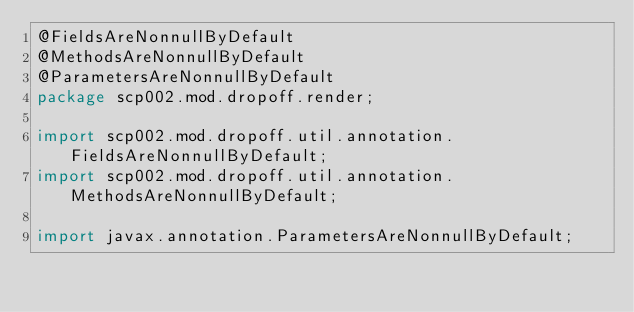<code> <loc_0><loc_0><loc_500><loc_500><_Java_>@FieldsAreNonnullByDefault
@MethodsAreNonnullByDefault
@ParametersAreNonnullByDefault
package scp002.mod.dropoff.render;

import scp002.mod.dropoff.util.annotation.FieldsAreNonnullByDefault;
import scp002.mod.dropoff.util.annotation.MethodsAreNonnullByDefault;

import javax.annotation.ParametersAreNonnullByDefault;
</code> 